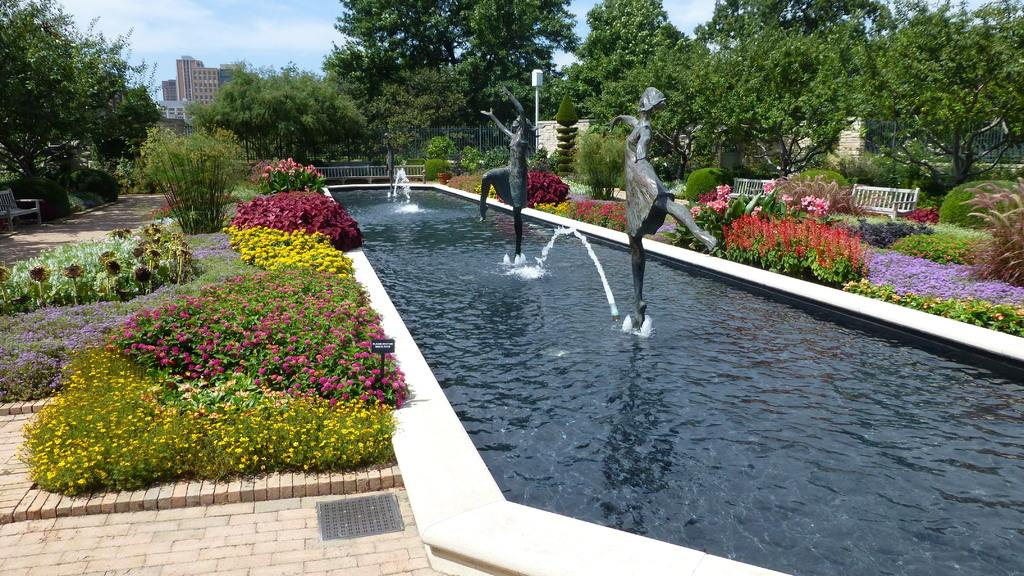What type of location is shown in the image? The image depicts a garden. What is the main feature in the middle of the garden? There is a fountain in the middle of the garden. What can be observed about the plant life in the garden? There are various plants with different flowers in the garden. What can be seen in the background of the image? Trees and buildings are visible in the background of the image. How many pigs are playing with the cactus in the garden? There are no pigs or cactus present in the image; it features a garden with a fountain and various plants. What type of lace is draped over the trees in the background? There is no lace visible in the image; only trees and buildings can be seen in the background. 